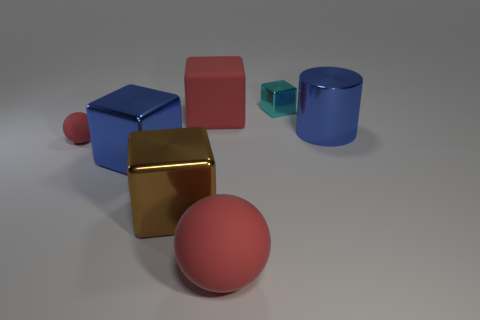Subtract all big red blocks. How many blocks are left? 3 Add 1 small blue matte spheres. How many objects exist? 8 Subtract all cyan cubes. How many cubes are left? 3 Subtract 2 spheres. How many spheres are left? 0 Subtract all balls. How many objects are left? 5 Subtract all cyan balls. Subtract all brown cylinders. How many balls are left? 2 Subtract all large yellow rubber balls. Subtract all tiny red spheres. How many objects are left? 6 Add 6 big blue things. How many big blue things are left? 8 Add 5 tiny red matte spheres. How many tiny red matte spheres exist? 6 Subtract 0 cyan cylinders. How many objects are left? 7 